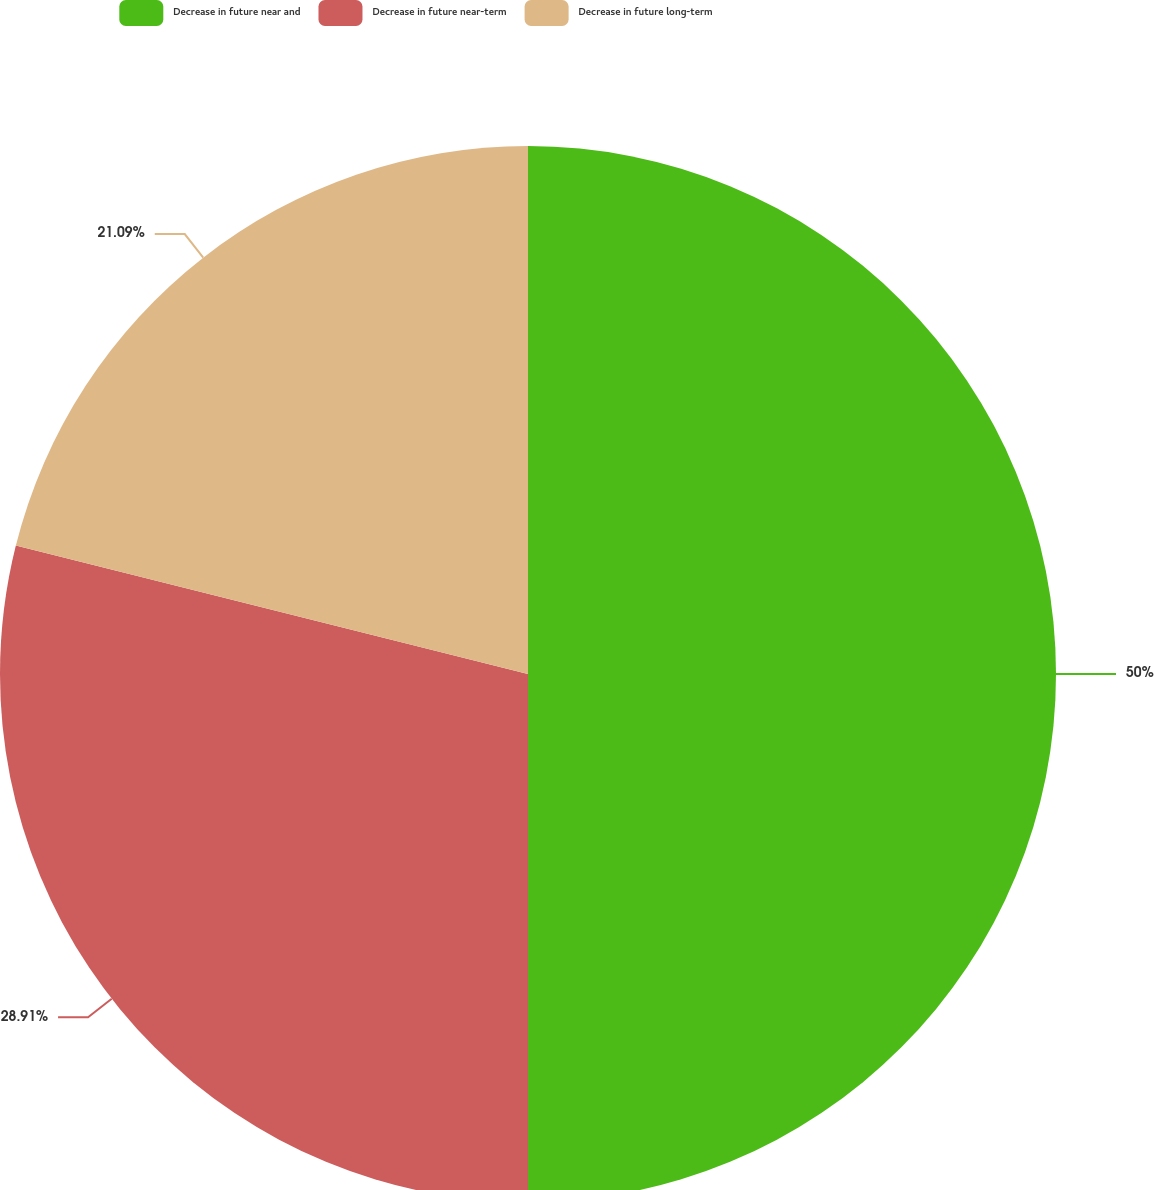<chart> <loc_0><loc_0><loc_500><loc_500><pie_chart><fcel>Decrease in future near and<fcel>Decrease in future near-term<fcel>Decrease in future long-term<nl><fcel>50.0%<fcel>28.91%<fcel>21.09%<nl></chart> 